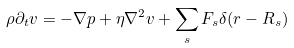<formula> <loc_0><loc_0><loc_500><loc_500>\rho \partial _ { t } { v } = - \nabla p + \eta \nabla ^ { 2 } { v } + \sum _ { s } { F } _ { s } \delta ( { r - R } _ { s } )</formula> 